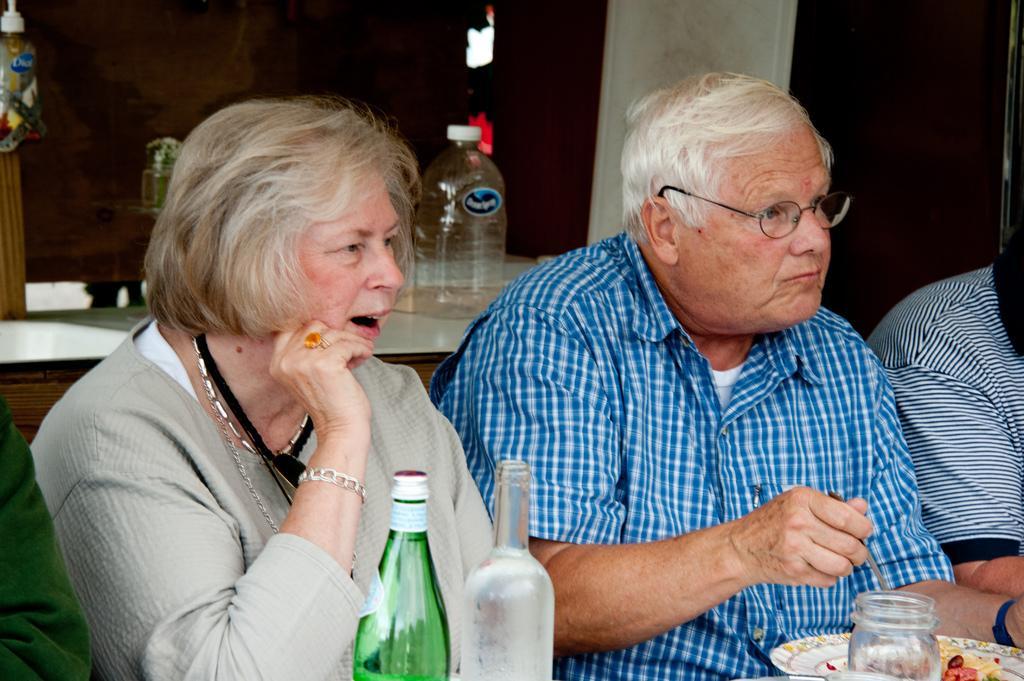Please provide a concise description of this image. In this picture we can see three persons. Here we can see two bottles and a plate. this is a food. This is a jar. This man is holding a spoon in his hand. Here we can see one woman with an expression aww. On the background we can see a bottle on the table. 